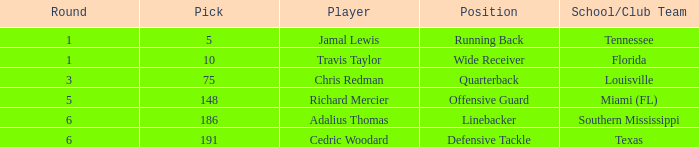What's the highest round that louisville drafted into when their pick was over 75? None. 